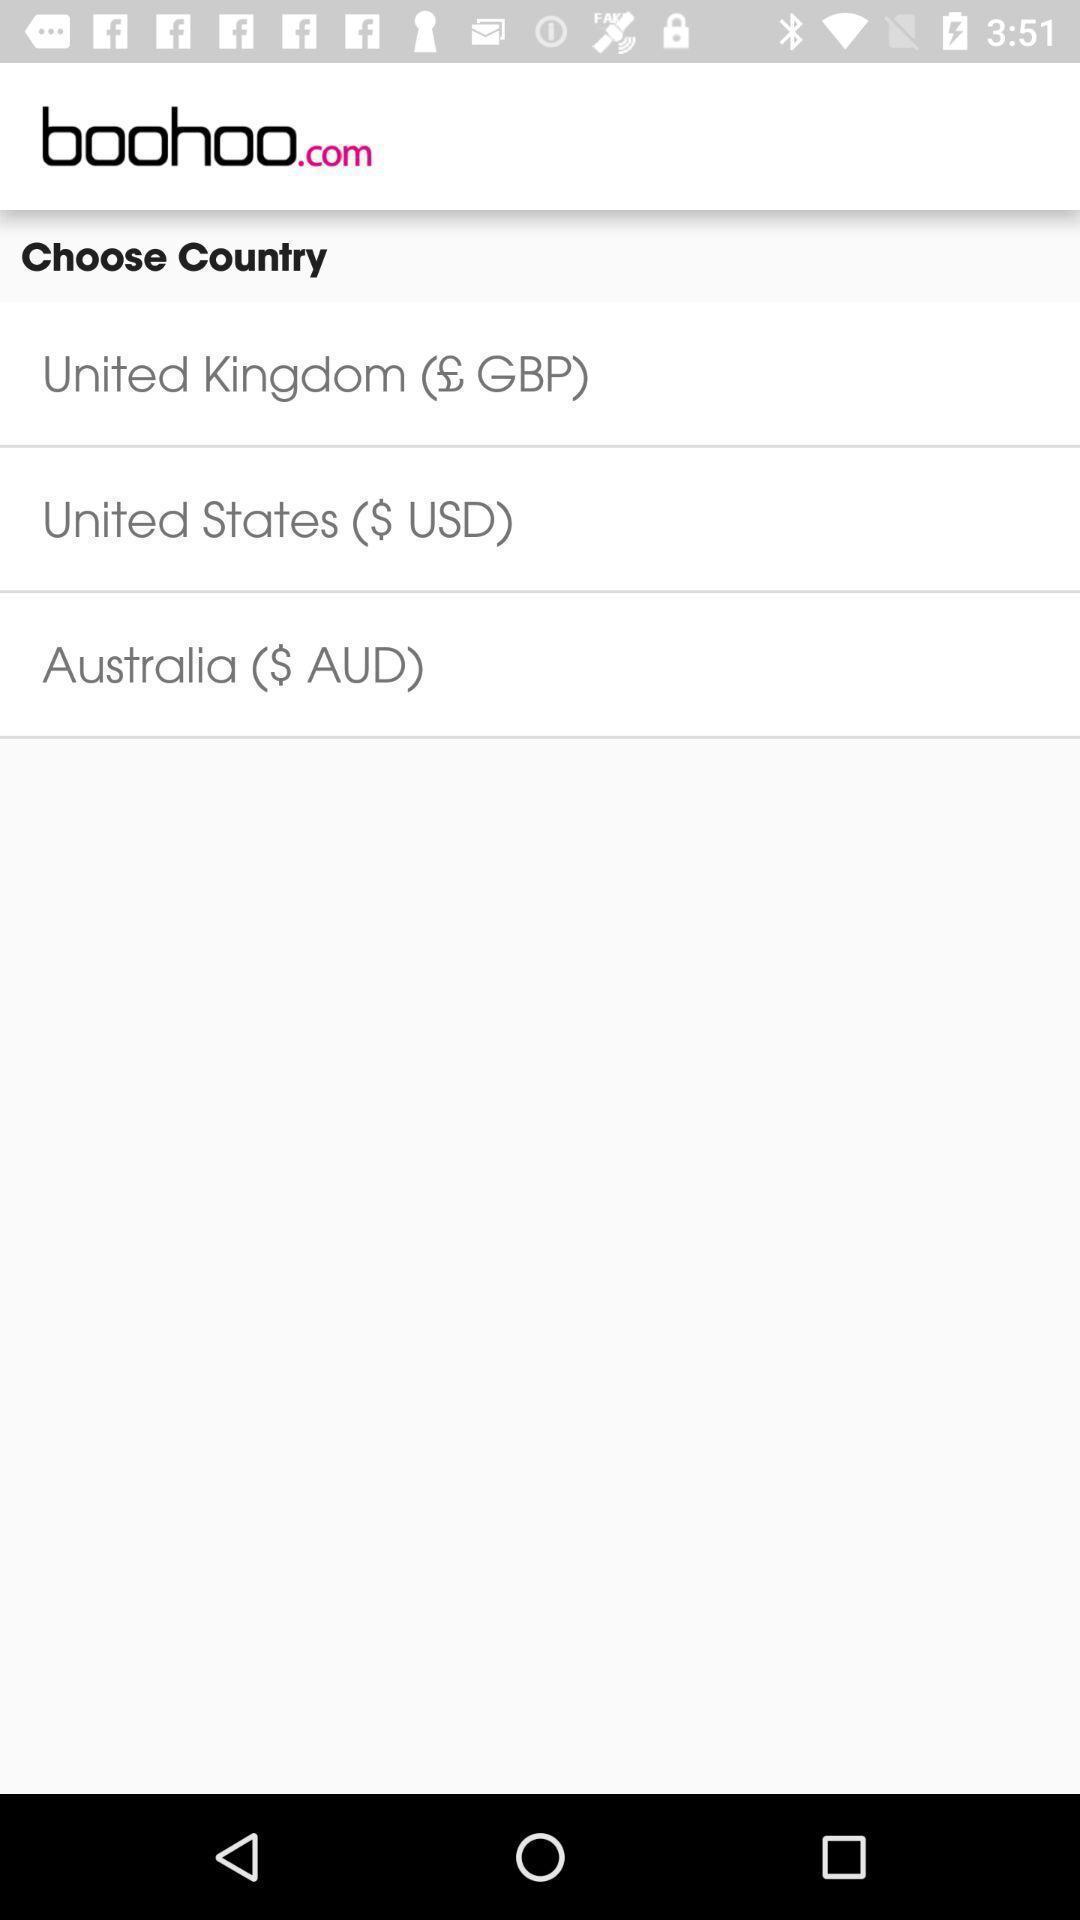Provide a detailed account of this screenshot. Page showing country selection options. 